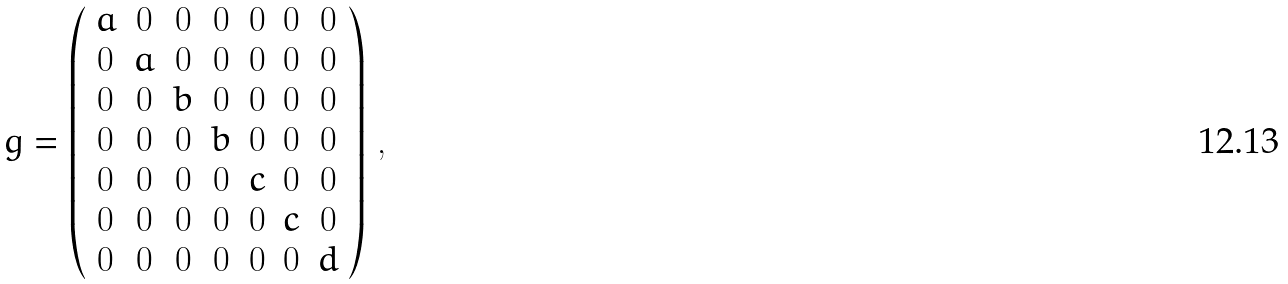Convert formula to latex. <formula><loc_0><loc_0><loc_500><loc_500>g = \left ( \begin{array} { c c c c c c c } a & 0 & 0 & 0 & 0 & 0 & 0 \\ 0 & a & 0 & 0 & 0 & 0 & 0 \\ 0 & 0 & b & 0 & 0 & 0 & 0 \\ 0 & 0 & 0 & b & 0 & 0 & 0 \\ 0 & 0 & 0 & 0 & c & 0 & 0 \\ 0 & 0 & 0 & 0 & 0 & c & 0 \\ 0 & 0 & 0 & 0 & 0 & 0 & d \\ \end{array} \right ) \, ,</formula> 